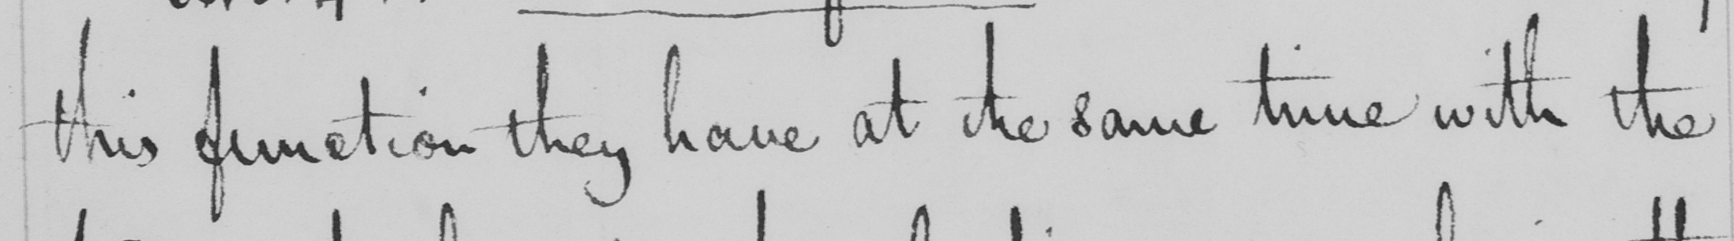Please transcribe the handwritten text in this image. this function they have at the same time with the 